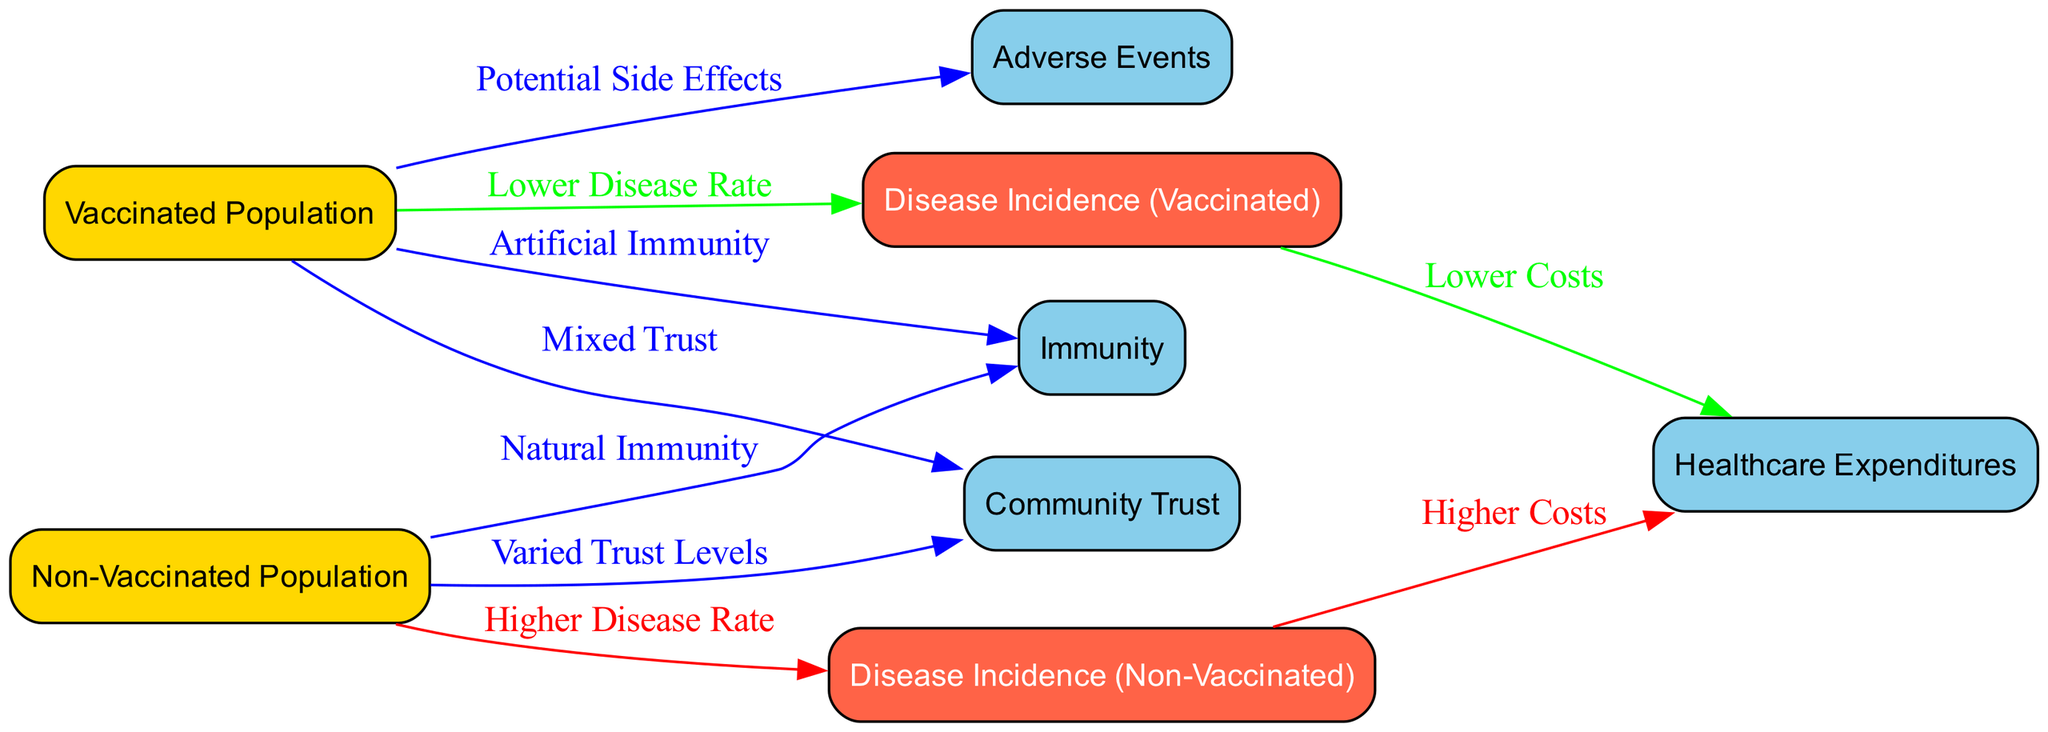What is the disease incidence for the vaccinated population? The diagram indicates that the disease incidence for the vaccinated population is described as "Lower Disease Rate", which suggests a numeric or relative representation of disease cases that is lower compared to the non-vaccinated population.
Answer: Lower Disease Rate What color represents the non-vaccinated population nodes? In the diagram, the nodes representing the non-vaccinated population are filled with a gold color, as indicated by the node's background color code which is included systematically for populations.
Answer: Gold How many nodes are there in the diagram? The diagram contains a total of 8 nodes, which are explicitly listed, including different population groups and their related health outcomes.
Answer: 8 What do healthcare expenditures show for non-vaccinated populations? The diagram connects the non-vaccinated population to healthcare expenditures showing it has "Higher Costs", indicating that the health expenditures for this group are elevated compared to the vaccinated counterparts.
Answer: Higher Costs What type of immunity is associated with the non-vaccinated population? The diagram labels the immunity associated with the non-vaccinated population as "Natural Immunity", which denotes how immunity is built through natural exposure to diseases.
Answer: Natural Immunity How do adverse events relate to the vaccinated population? The diagram shows a connection that indicates vaccinated populations may experience "Potential Side Effects", which emphasizes that there is a risk associated with vaccination that can lead to adverse effects.
Answer: Potential Side Effects Which population has mixed trust levels according to the diagram? The diagram specifies that the vaccinated population has "Mixed Trust", indicating the variability in trust levels towards vaccination within the community involved.
Answer: Mixed Trust What are the healthcare expenditures for vaccinated populations connected to? The healthcare expenditures for vaccinated populations are connected to "Lower Costs", as per the labeling in the diagram, indicating reductions in financial health burdens for this group.
Answer: Lower Costs What does the arrow from vaccinated population to immunity indicate? The diagram illustrates an arrow pointing from the vaccinated population to immunity, which is labeled "Artificial Immunity", indicating that vaccinations confer immunity through artificial means rather than natural exposure.
Answer: Artificial Immunity 